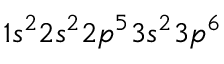<formula> <loc_0><loc_0><loc_500><loc_500>1 s ^ { 2 } 2 s ^ { 2 } 2 p ^ { 5 } 3 s ^ { 2 } 3 p ^ { 6 }</formula> 